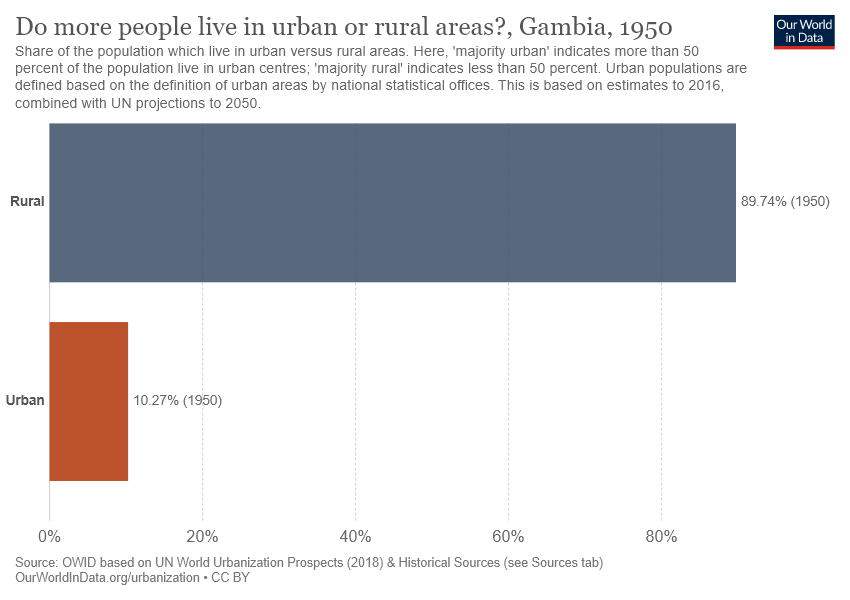Indicate a few pertinent items in this graphic. The rural option has a value of 0.8974... The average between "Rural" and "Urban" is approximately 0.5001. 